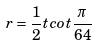<formula> <loc_0><loc_0><loc_500><loc_500>r = \frac { 1 } { 2 } t c o t \frac { \pi } { 6 4 }</formula> 